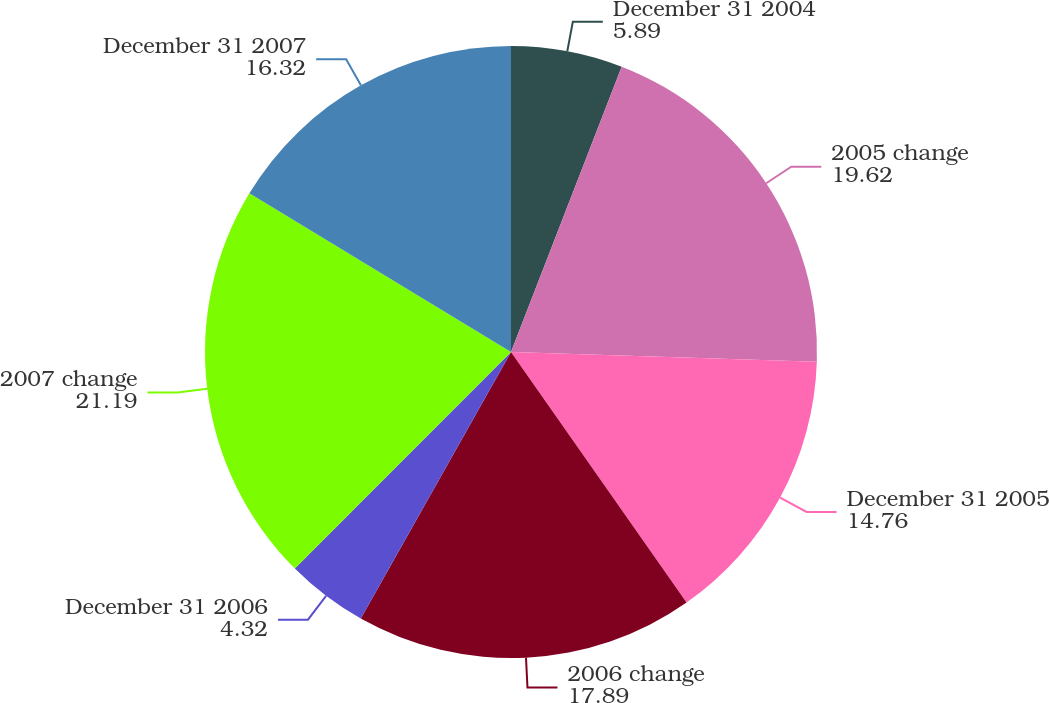<chart> <loc_0><loc_0><loc_500><loc_500><pie_chart><fcel>December 31 2004<fcel>2005 change<fcel>December 31 2005<fcel>2006 change<fcel>December 31 2006<fcel>2007 change<fcel>December 31 2007<nl><fcel>5.89%<fcel>19.62%<fcel>14.76%<fcel>17.89%<fcel>4.32%<fcel>21.19%<fcel>16.32%<nl></chart> 